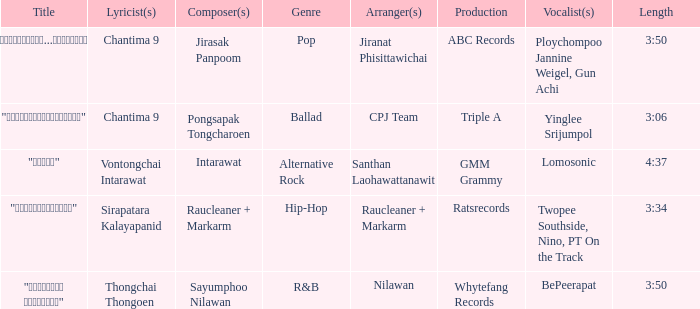Who was the arranger of "ขอโทษ"? Santhan Laohawattanawit. Parse the full table. {'header': ['Title', 'Lyricist(s)', 'Composer(s)', 'Genre', 'Arranger(s)', 'Production', 'Vocalist(s)', 'Length'], 'rows': [['"เรายังรักกัน...ไม่ใช่เหรอ"', 'Chantima 9', 'Jirasak Panpoom', 'Pop', 'Jiranat Phisittawichai', 'ABC Records', 'Ploychompoo Jannine Weigel, Gun Achi', '3:50'], ['"นางฟ้าตาชั้นเดียว"', 'Chantima 9', 'Pongsapak Tongcharoen', 'Ballad', 'CPJ Team', 'Triple A', 'Yinglee Srijumpol', '3:06'], ['"ขอโทษ"', 'Vontongchai Intarawat', 'Intarawat', 'Alternative Rock', 'Santhan Laohawattanawit', 'GMM Grammy', 'Lomosonic', '4:37'], ['"แค่อยากให้รู้"', 'Sirapatara Kalayapanid', 'Raucleaner + Markarm', 'Hip-Hop', 'Raucleaner + Markarm', 'Ratsrecords', 'Twopee Southside, Nino, PT On the Track', '3:34'], ['"เลือกลืม เลือกจำ"', 'Thongchai Thongoen', 'Sayumphoo Nilawan', 'R&B', 'Nilawan', 'Whytefang Records', 'BePeerapat', '3:50']]} 